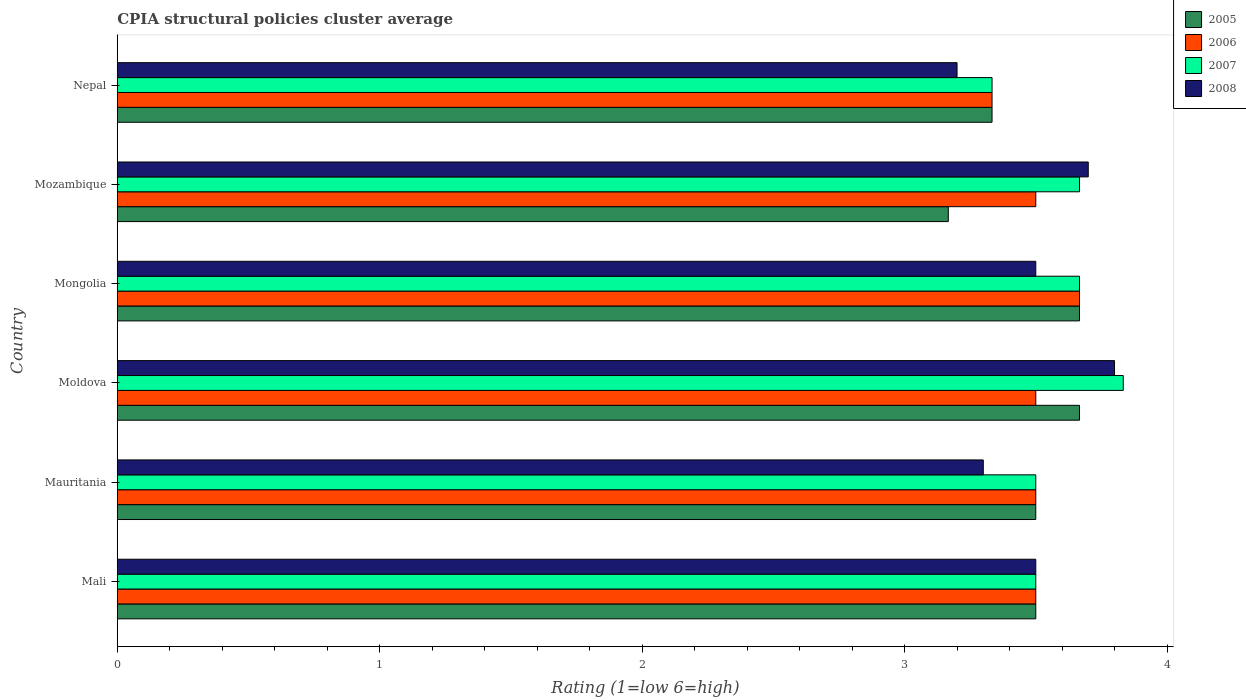How many groups of bars are there?
Make the answer very short. 6. What is the label of the 2nd group of bars from the top?
Your answer should be compact. Mozambique. Across all countries, what is the maximum CPIA rating in 2005?
Keep it short and to the point. 3.67. Across all countries, what is the minimum CPIA rating in 2006?
Your answer should be compact. 3.33. In which country was the CPIA rating in 2006 maximum?
Keep it short and to the point. Mongolia. In which country was the CPIA rating in 2008 minimum?
Keep it short and to the point. Nepal. What is the total CPIA rating in 2005 in the graph?
Provide a succinct answer. 20.83. What is the difference between the CPIA rating in 2007 in Mauritania and that in Mongolia?
Offer a terse response. -0.17. What is the difference between the CPIA rating in 2008 in Mauritania and the CPIA rating in 2005 in Nepal?
Your response must be concise. -0.03. What is the average CPIA rating in 2006 per country?
Your answer should be compact. 3.5. What is the ratio of the CPIA rating in 2007 in Mauritania to that in Mozambique?
Make the answer very short. 0.95. Is the difference between the CPIA rating in 2006 in Mauritania and Mozambique greater than the difference between the CPIA rating in 2008 in Mauritania and Mozambique?
Offer a terse response. Yes. What is the difference between the highest and the second highest CPIA rating in 2008?
Provide a succinct answer. 0.1. What is the difference between the highest and the lowest CPIA rating in 2007?
Make the answer very short. 0.5. In how many countries, is the CPIA rating in 2005 greater than the average CPIA rating in 2005 taken over all countries?
Your response must be concise. 4. Is the sum of the CPIA rating in 2006 in Mauritania and Mozambique greater than the maximum CPIA rating in 2007 across all countries?
Make the answer very short. Yes. What does the 4th bar from the bottom in Mozambique represents?
Your response must be concise. 2008. Is it the case that in every country, the sum of the CPIA rating in 2007 and CPIA rating in 2005 is greater than the CPIA rating in 2008?
Your response must be concise. Yes. Are the values on the major ticks of X-axis written in scientific E-notation?
Make the answer very short. No. Does the graph contain grids?
Provide a succinct answer. No. Where does the legend appear in the graph?
Ensure brevity in your answer.  Top right. How many legend labels are there?
Ensure brevity in your answer.  4. What is the title of the graph?
Provide a short and direct response. CPIA structural policies cluster average. What is the label or title of the Y-axis?
Provide a short and direct response. Country. What is the Rating (1=low 6=high) in 2006 in Mali?
Give a very brief answer. 3.5. What is the Rating (1=low 6=high) in 2008 in Mali?
Ensure brevity in your answer.  3.5. What is the Rating (1=low 6=high) of 2005 in Mauritania?
Make the answer very short. 3.5. What is the Rating (1=low 6=high) of 2008 in Mauritania?
Your answer should be very brief. 3.3. What is the Rating (1=low 6=high) of 2005 in Moldova?
Give a very brief answer. 3.67. What is the Rating (1=low 6=high) of 2006 in Moldova?
Give a very brief answer. 3.5. What is the Rating (1=low 6=high) of 2007 in Moldova?
Your answer should be very brief. 3.83. What is the Rating (1=low 6=high) in 2005 in Mongolia?
Give a very brief answer. 3.67. What is the Rating (1=low 6=high) of 2006 in Mongolia?
Offer a terse response. 3.67. What is the Rating (1=low 6=high) of 2007 in Mongolia?
Make the answer very short. 3.67. What is the Rating (1=low 6=high) of 2005 in Mozambique?
Your response must be concise. 3.17. What is the Rating (1=low 6=high) of 2007 in Mozambique?
Offer a very short reply. 3.67. What is the Rating (1=low 6=high) in 2008 in Mozambique?
Ensure brevity in your answer.  3.7. What is the Rating (1=low 6=high) of 2005 in Nepal?
Provide a short and direct response. 3.33. What is the Rating (1=low 6=high) of 2006 in Nepal?
Your answer should be compact. 3.33. What is the Rating (1=low 6=high) in 2007 in Nepal?
Provide a succinct answer. 3.33. Across all countries, what is the maximum Rating (1=low 6=high) in 2005?
Keep it short and to the point. 3.67. Across all countries, what is the maximum Rating (1=low 6=high) in 2006?
Ensure brevity in your answer.  3.67. Across all countries, what is the maximum Rating (1=low 6=high) of 2007?
Your answer should be compact. 3.83. Across all countries, what is the minimum Rating (1=low 6=high) of 2005?
Provide a short and direct response. 3.17. Across all countries, what is the minimum Rating (1=low 6=high) of 2006?
Give a very brief answer. 3.33. Across all countries, what is the minimum Rating (1=low 6=high) of 2007?
Your response must be concise. 3.33. Across all countries, what is the minimum Rating (1=low 6=high) of 2008?
Offer a very short reply. 3.2. What is the total Rating (1=low 6=high) in 2005 in the graph?
Make the answer very short. 20.83. What is the difference between the Rating (1=low 6=high) in 2005 in Mali and that in Mauritania?
Your answer should be very brief. 0. What is the difference between the Rating (1=low 6=high) in 2008 in Mali and that in Mauritania?
Your response must be concise. 0.2. What is the difference between the Rating (1=low 6=high) in 2005 in Mali and that in Moldova?
Ensure brevity in your answer.  -0.17. What is the difference between the Rating (1=low 6=high) in 2006 in Mali and that in Moldova?
Provide a succinct answer. 0. What is the difference between the Rating (1=low 6=high) in 2008 in Mali and that in Mongolia?
Keep it short and to the point. 0. What is the difference between the Rating (1=low 6=high) in 2005 in Mali and that in Mozambique?
Provide a succinct answer. 0.33. What is the difference between the Rating (1=low 6=high) in 2006 in Mali and that in Mozambique?
Give a very brief answer. 0. What is the difference between the Rating (1=low 6=high) in 2007 in Mali and that in Mozambique?
Offer a very short reply. -0.17. What is the difference between the Rating (1=low 6=high) in 2008 in Mali and that in Mozambique?
Ensure brevity in your answer.  -0.2. What is the difference between the Rating (1=low 6=high) in 2006 in Mali and that in Nepal?
Offer a terse response. 0.17. What is the difference between the Rating (1=low 6=high) in 2007 in Mali and that in Nepal?
Offer a terse response. 0.17. What is the difference between the Rating (1=low 6=high) in 2008 in Mali and that in Nepal?
Ensure brevity in your answer.  0.3. What is the difference between the Rating (1=low 6=high) in 2006 in Mauritania and that in Moldova?
Offer a terse response. 0. What is the difference between the Rating (1=low 6=high) of 2007 in Mauritania and that in Moldova?
Your answer should be very brief. -0.33. What is the difference between the Rating (1=low 6=high) of 2008 in Mauritania and that in Moldova?
Keep it short and to the point. -0.5. What is the difference between the Rating (1=low 6=high) in 2005 in Mauritania and that in Mongolia?
Make the answer very short. -0.17. What is the difference between the Rating (1=low 6=high) in 2006 in Mauritania and that in Mongolia?
Offer a very short reply. -0.17. What is the difference between the Rating (1=low 6=high) of 2007 in Mauritania and that in Mongolia?
Make the answer very short. -0.17. What is the difference between the Rating (1=low 6=high) of 2005 in Mauritania and that in Mozambique?
Your answer should be compact. 0.33. What is the difference between the Rating (1=low 6=high) in 2006 in Mauritania and that in Mozambique?
Provide a short and direct response. 0. What is the difference between the Rating (1=low 6=high) in 2008 in Mauritania and that in Mozambique?
Provide a short and direct response. -0.4. What is the difference between the Rating (1=low 6=high) of 2007 in Mauritania and that in Nepal?
Keep it short and to the point. 0.17. What is the difference between the Rating (1=low 6=high) in 2006 in Moldova and that in Mongolia?
Provide a succinct answer. -0.17. What is the difference between the Rating (1=low 6=high) of 2007 in Moldova and that in Mongolia?
Ensure brevity in your answer.  0.17. What is the difference between the Rating (1=low 6=high) of 2006 in Moldova and that in Mozambique?
Provide a short and direct response. 0. What is the difference between the Rating (1=low 6=high) in 2008 in Moldova and that in Mozambique?
Provide a succinct answer. 0.1. What is the difference between the Rating (1=low 6=high) of 2005 in Moldova and that in Nepal?
Ensure brevity in your answer.  0.33. What is the difference between the Rating (1=low 6=high) of 2006 in Moldova and that in Nepal?
Offer a terse response. 0.17. What is the difference between the Rating (1=low 6=high) of 2007 in Moldova and that in Nepal?
Keep it short and to the point. 0.5. What is the difference between the Rating (1=low 6=high) in 2008 in Mongolia and that in Mozambique?
Your answer should be compact. -0.2. What is the difference between the Rating (1=low 6=high) in 2006 in Mongolia and that in Nepal?
Keep it short and to the point. 0.33. What is the difference between the Rating (1=low 6=high) in 2008 in Mozambique and that in Nepal?
Your answer should be compact. 0.5. What is the difference between the Rating (1=low 6=high) of 2005 in Mali and the Rating (1=low 6=high) of 2008 in Mauritania?
Give a very brief answer. 0.2. What is the difference between the Rating (1=low 6=high) in 2007 in Mali and the Rating (1=low 6=high) in 2008 in Mauritania?
Offer a terse response. 0.2. What is the difference between the Rating (1=low 6=high) in 2005 in Mali and the Rating (1=low 6=high) in 2006 in Moldova?
Offer a very short reply. 0. What is the difference between the Rating (1=low 6=high) of 2005 in Mali and the Rating (1=low 6=high) of 2008 in Moldova?
Ensure brevity in your answer.  -0.3. What is the difference between the Rating (1=low 6=high) in 2006 in Mali and the Rating (1=low 6=high) in 2007 in Moldova?
Keep it short and to the point. -0.33. What is the difference between the Rating (1=low 6=high) in 2005 in Mali and the Rating (1=low 6=high) in 2008 in Mongolia?
Make the answer very short. 0. What is the difference between the Rating (1=low 6=high) of 2006 in Mali and the Rating (1=low 6=high) of 2008 in Mongolia?
Make the answer very short. 0. What is the difference between the Rating (1=low 6=high) in 2007 in Mali and the Rating (1=low 6=high) in 2008 in Mongolia?
Give a very brief answer. 0. What is the difference between the Rating (1=low 6=high) of 2005 in Mali and the Rating (1=low 6=high) of 2008 in Mozambique?
Ensure brevity in your answer.  -0.2. What is the difference between the Rating (1=low 6=high) of 2007 in Mali and the Rating (1=low 6=high) of 2008 in Mozambique?
Offer a terse response. -0.2. What is the difference between the Rating (1=low 6=high) in 2006 in Mali and the Rating (1=low 6=high) in 2007 in Nepal?
Provide a short and direct response. 0.17. What is the difference between the Rating (1=low 6=high) in 2007 in Mauritania and the Rating (1=low 6=high) in 2008 in Moldova?
Offer a very short reply. -0.3. What is the difference between the Rating (1=low 6=high) of 2005 in Mauritania and the Rating (1=low 6=high) of 2007 in Mongolia?
Offer a very short reply. -0.17. What is the difference between the Rating (1=low 6=high) in 2005 in Mauritania and the Rating (1=low 6=high) in 2008 in Mongolia?
Give a very brief answer. 0. What is the difference between the Rating (1=low 6=high) in 2006 in Mauritania and the Rating (1=low 6=high) in 2007 in Mongolia?
Offer a very short reply. -0.17. What is the difference between the Rating (1=low 6=high) of 2007 in Mauritania and the Rating (1=low 6=high) of 2008 in Mongolia?
Your answer should be very brief. 0. What is the difference between the Rating (1=low 6=high) of 2005 in Mauritania and the Rating (1=low 6=high) of 2007 in Mozambique?
Your answer should be compact. -0.17. What is the difference between the Rating (1=low 6=high) of 2005 in Mauritania and the Rating (1=low 6=high) of 2008 in Mozambique?
Your answer should be compact. -0.2. What is the difference between the Rating (1=low 6=high) of 2006 in Mauritania and the Rating (1=low 6=high) of 2007 in Mozambique?
Offer a very short reply. -0.17. What is the difference between the Rating (1=low 6=high) in 2006 in Mauritania and the Rating (1=low 6=high) in 2008 in Mozambique?
Provide a succinct answer. -0.2. What is the difference between the Rating (1=low 6=high) in 2005 in Mauritania and the Rating (1=low 6=high) in 2006 in Nepal?
Keep it short and to the point. 0.17. What is the difference between the Rating (1=low 6=high) of 2005 in Mauritania and the Rating (1=low 6=high) of 2007 in Nepal?
Keep it short and to the point. 0.17. What is the difference between the Rating (1=low 6=high) in 2005 in Moldova and the Rating (1=low 6=high) in 2007 in Mongolia?
Your answer should be compact. 0. What is the difference between the Rating (1=low 6=high) of 2005 in Moldova and the Rating (1=low 6=high) of 2008 in Mongolia?
Offer a very short reply. 0.17. What is the difference between the Rating (1=low 6=high) in 2005 in Moldova and the Rating (1=low 6=high) in 2006 in Mozambique?
Offer a very short reply. 0.17. What is the difference between the Rating (1=low 6=high) in 2005 in Moldova and the Rating (1=low 6=high) in 2007 in Mozambique?
Make the answer very short. 0. What is the difference between the Rating (1=low 6=high) of 2005 in Moldova and the Rating (1=low 6=high) of 2008 in Mozambique?
Give a very brief answer. -0.03. What is the difference between the Rating (1=low 6=high) of 2006 in Moldova and the Rating (1=low 6=high) of 2007 in Mozambique?
Offer a terse response. -0.17. What is the difference between the Rating (1=low 6=high) in 2007 in Moldova and the Rating (1=low 6=high) in 2008 in Mozambique?
Keep it short and to the point. 0.13. What is the difference between the Rating (1=low 6=high) in 2005 in Moldova and the Rating (1=low 6=high) in 2008 in Nepal?
Give a very brief answer. 0.47. What is the difference between the Rating (1=low 6=high) in 2006 in Moldova and the Rating (1=low 6=high) in 2007 in Nepal?
Give a very brief answer. 0.17. What is the difference between the Rating (1=low 6=high) of 2007 in Moldova and the Rating (1=low 6=high) of 2008 in Nepal?
Your answer should be very brief. 0.63. What is the difference between the Rating (1=low 6=high) of 2005 in Mongolia and the Rating (1=low 6=high) of 2006 in Mozambique?
Your answer should be compact. 0.17. What is the difference between the Rating (1=low 6=high) in 2005 in Mongolia and the Rating (1=low 6=high) in 2007 in Mozambique?
Your answer should be compact. 0. What is the difference between the Rating (1=low 6=high) of 2005 in Mongolia and the Rating (1=low 6=high) of 2008 in Mozambique?
Your response must be concise. -0.03. What is the difference between the Rating (1=low 6=high) in 2006 in Mongolia and the Rating (1=low 6=high) in 2007 in Mozambique?
Ensure brevity in your answer.  0. What is the difference between the Rating (1=low 6=high) of 2006 in Mongolia and the Rating (1=low 6=high) of 2008 in Mozambique?
Offer a very short reply. -0.03. What is the difference between the Rating (1=low 6=high) in 2007 in Mongolia and the Rating (1=low 6=high) in 2008 in Mozambique?
Provide a short and direct response. -0.03. What is the difference between the Rating (1=low 6=high) in 2005 in Mongolia and the Rating (1=low 6=high) in 2006 in Nepal?
Your answer should be very brief. 0.33. What is the difference between the Rating (1=low 6=high) in 2005 in Mongolia and the Rating (1=low 6=high) in 2007 in Nepal?
Provide a succinct answer. 0.33. What is the difference between the Rating (1=low 6=high) in 2005 in Mongolia and the Rating (1=low 6=high) in 2008 in Nepal?
Offer a terse response. 0.47. What is the difference between the Rating (1=low 6=high) in 2006 in Mongolia and the Rating (1=low 6=high) in 2007 in Nepal?
Make the answer very short. 0.33. What is the difference between the Rating (1=low 6=high) in 2006 in Mongolia and the Rating (1=low 6=high) in 2008 in Nepal?
Provide a short and direct response. 0.47. What is the difference between the Rating (1=low 6=high) of 2007 in Mongolia and the Rating (1=low 6=high) of 2008 in Nepal?
Your response must be concise. 0.47. What is the difference between the Rating (1=low 6=high) in 2005 in Mozambique and the Rating (1=low 6=high) in 2006 in Nepal?
Offer a terse response. -0.17. What is the difference between the Rating (1=low 6=high) of 2005 in Mozambique and the Rating (1=low 6=high) of 2007 in Nepal?
Provide a short and direct response. -0.17. What is the difference between the Rating (1=low 6=high) of 2005 in Mozambique and the Rating (1=low 6=high) of 2008 in Nepal?
Offer a terse response. -0.03. What is the difference between the Rating (1=low 6=high) of 2007 in Mozambique and the Rating (1=low 6=high) of 2008 in Nepal?
Ensure brevity in your answer.  0.47. What is the average Rating (1=low 6=high) of 2005 per country?
Offer a very short reply. 3.47. What is the average Rating (1=low 6=high) of 2007 per country?
Your answer should be compact. 3.58. What is the difference between the Rating (1=low 6=high) of 2005 and Rating (1=low 6=high) of 2006 in Mali?
Provide a short and direct response. 0. What is the difference between the Rating (1=low 6=high) of 2006 and Rating (1=low 6=high) of 2007 in Mali?
Provide a succinct answer. 0. What is the difference between the Rating (1=low 6=high) of 2005 and Rating (1=low 6=high) of 2006 in Mauritania?
Make the answer very short. 0. What is the difference between the Rating (1=low 6=high) in 2006 and Rating (1=low 6=high) in 2007 in Mauritania?
Offer a terse response. 0. What is the difference between the Rating (1=low 6=high) of 2006 and Rating (1=low 6=high) of 2008 in Mauritania?
Offer a very short reply. 0.2. What is the difference between the Rating (1=low 6=high) of 2005 and Rating (1=low 6=high) of 2008 in Moldova?
Offer a terse response. -0.13. What is the difference between the Rating (1=low 6=high) in 2006 and Rating (1=low 6=high) in 2008 in Moldova?
Provide a short and direct response. -0.3. What is the difference between the Rating (1=low 6=high) in 2005 and Rating (1=low 6=high) in 2006 in Mongolia?
Your answer should be very brief. 0. What is the difference between the Rating (1=low 6=high) of 2006 and Rating (1=low 6=high) of 2007 in Mongolia?
Your answer should be compact. 0. What is the difference between the Rating (1=low 6=high) of 2005 and Rating (1=low 6=high) of 2006 in Mozambique?
Provide a succinct answer. -0.33. What is the difference between the Rating (1=low 6=high) in 2005 and Rating (1=low 6=high) in 2007 in Mozambique?
Your answer should be compact. -0.5. What is the difference between the Rating (1=low 6=high) in 2005 and Rating (1=low 6=high) in 2008 in Mozambique?
Keep it short and to the point. -0.53. What is the difference between the Rating (1=low 6=high) of 2006 and Rating (1=low 6=high) of 2008 in Mozambique?
Your answer should be compact. -0.2. What is the difference between the Rating (1=low 6=high) of 2007 and Rating (1=low 6=high) of 2008 in Mozambique?
Your answer should be very brief. -0.03. What is the difference between the Rating (1=low 6=high) of 2005 and Rating (1=low 6=high) of 2008 in Nepal?
Offer a terse response. 0.13. What is the difference between the Rating (1=low 6=high) of 2006 and Rating (1=low 6=high) of 2007 in Nepal?
Provide a succinct answer. 0. What is the difference between the Rating (1=low 6=high) of 2006 and Rating (1=low 6=high) of 2008 in Nepal?
Your answer should be very brief. 0.13. What is the difference between the Rating (1=low 6=high) in 2007 and Rating (1=low 6=high) in 2008 in Nepal?
Offer a very short reply. 0.13. What is the ratio of the Rating (1=low 6=high) of 2006 in Mali to that in Mauritania?
Give a very brief answer. 1. What is the ratio of the Rating (1=low 6=high) in 2007 in Mali to that in Mauritania?
Your answer should be compact. 1. What is the ratio of the Rating (1=low 6=high) in 2008 in Mali to that in Mauritania?
Your answer should be very brief. 1.06. What is the ratio of the Rating (1=low 6=high) in 2005 in Mali to that in Moldova?
Give a very brief answer. 0.95. What is the ratio of the Rating (1=low 6=high) of 2006 in Mali to that in Moldova?
Offer a terse response. 1. What is the ratio of the Rating (1=low 6=high) in 2008 in Mali to that in Moldova?
Your response must be concise. 0.92. What is the ratio of the Rating (1=low 6=high) of 2005 in Mali to that in Mongolia?
Provide a short and direct response. 0.95. What is the ratio of the Rating (1=low 6=high) of 2006 in Mali to that in Mongolia?
Provide a succinct answer. 0.95. What is the ratio of the Rating (1=low 6=high) of 2007 in Mali to that in Mongolia?
Your answer should be compact. 0.95. What is the ratio of the Rating (1=low 6=high) of 2008 in Mali to that in Mongolia?
Keep it short and to the point. 1. What is the ratio of the Rating (1=low 6=high) of 2005 in Mali to that in Mozambique?
Your answer should be compact. 1.11. What is the ratio of the Rating (1=low 6=high) in 2006 in Mali to that in Mozambique?
Offer a very short reply. 1. What is the ratio of the Rating (1=low 6=high) of 2007 in Mali to that in Mozambique?
Give a very brief answer. 0.95. What is the ratio of the Rating (1=low 6=high) in 2008 in Mali to that in Mozambique?
Your response must be concise. 0.95. What is the ratio of the Rating (1=low 6=high) in 2008 in Mali to that in Nepal?
Offer a terse response. 1.09. What is the ratio of the Rating (1=low 6=high) in 2005 in Mauritania to that in Moldova?
Provide a succinct answer. 0.95. What is the ratio of the Rating (1=low 6=high) in 2008 in Mauritania to that in Moldova?
Offer a terse response. 0.87. What is the ratio of the Rating (1=low 6=high) of 2005 in Mauritania to that in Mongolia?
Provide a short and direct response. 0.95. What is the ratio of the Rating (1=low 6=high) of 2006 in Mauritania to that in Mongolia?
Your response must be concise. 0.95. What is the ratio of the Rating (1=low 6=high) in 2007 in Mauritania to that in Mongolia?
Give a very brief answer. 0.95. What is the ratio of the Rating (1=low 6=high) in 2008 in Mauritania to that in Mongolia?
Ensure brevity in your answer.  0.94. What is the ratio of the Rating (1=low 6=high) of 2005 in Mauritania to that in Mozambique?
Provide a short and direct response. 1.11. What is the ratio of the Rating (1=low 6=high) of 2007 in Mauritania to that in Mozambique?
Offer a terse response. 0.95. What is the ratio of the Rating (1=low 6=high) of 2008 in Mauritania to that in Mozambique?
Offer a terse response. 0.89. What is the ratio of the Rating (1=low 6=high) of 2006 in Mauritania to that in Nepal?
Keep it short and to the point. 1.05. What is the ratio of the Rating (1=low 6=high) in 2008 in Mauritania to that in Nepal?
Your answer should be very brief. 1.03. What is the ratio of the Rating (1=low 6=high) of 2006 in Moldova to that in Mongolia?
Provide a short and direct response. 0.95. What is the ratio of the Rating (1=low 6=high) of 2007 in Moldova to that in Mongolia?
Make the answer very short. 1.05. What is the ratio of the Rating (1=low 6=high) of 2008 in Moldova to that in Mongolia?
Your response must be concise. 1.09. What is the ratio of the Rating (1=low 6=high) in 2005 in Moldova to that in Mozambique?
Ensure brevity in your answer.  1.16. What is the ratio of the Rating (1=low 6=high) in 2006 in Moldova to that in Mozambique?
Keep it short and to the point. 1. What is the ratio of the Rating (1=low 6=high) in 2007 in Moldova to that in Mozambique?
Make the answer very short. 1.05. What is the ratio of the Rating (1=low 6=high) of 2005 in Moldova to that in Nepal?
Offer a very short reply. 1.1. What is the ratio of the Rating (1=low 6=high) of 2007 in Moldova to that in Nepal?
Make the answer very short. 1.15. What is the ratio of the Rating (1=low 6=high) in 2008 in Moldova to that in Nepal?
Your response must be concise. 1.19. What is the ratio of the Rating (1=low 6=high) in 2005 in Mongolia to that in Mozambique?
Offer a very short reply. 1.16. What is the ratio of the Rating (1=low 6=high) in 2006 in Mongolia to that in Mozambique?
Make the answer very short. 1.05. What is the ratio of the Rating (1=low 6=high) of 2008 in Mongolia to that in Mozambique?
Provide a succinct answer. 0.95. What is the ratio of the Rating (1=low 6=high) in 2005 in Mongolia to that in Nepal?
Offer a terse response. 1.1. What is the ratio of the Rating (1=low 6=high) in 2007 in Mongolia to that in Nepal?
Offer a terse response. 1.1. What is the ratio of the Rating (1=low 6=high) in 2008 in Mongolia to that in Nepal?
Ensure brevity in your answer.  1.09. What is the ratio of the Rating (1=low 6=high) in 2008 in Mozambique to that in Nepal?
Give a very brief answer. 1.16. What is the difference between the highest and the second highest Rating (1=low 6=high) in 2008?
Offer a terse response. 0.1. What is the difference between the highest and the lowest Rating (1=low 6=high) of 2006?
Make the answer very short. 0.33. What is the difference between the highest and the lowest Rating (1=low 6=high) of 2008?
Ensure brevity in your answer.  0.6. 